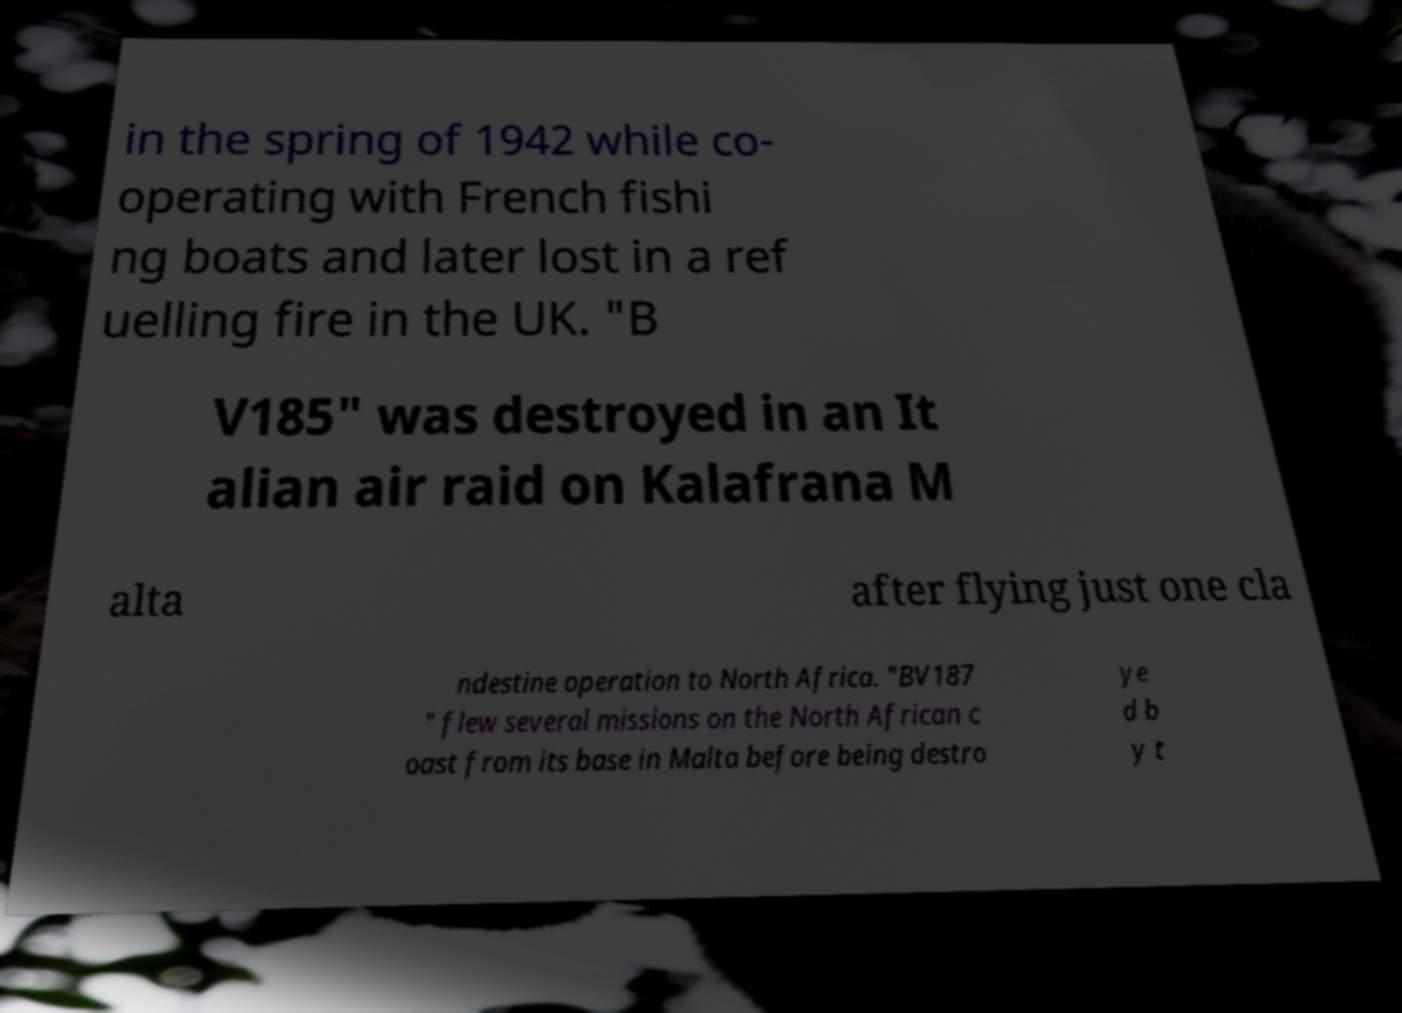What messages or text are displayed in this image? I need them in a readable, typed format. in the spring of 1942 while co- operating with French fishi ng boats and later lost in a ref uelling fire in the UK. "B V185" was destroyed in an It alian air raid on Kalafrana M alta after flying just one cla ndestine operation to North Africa. "BV187 " flew several missions on the North African c oast from its base in Malta before being destro ye d b y t 